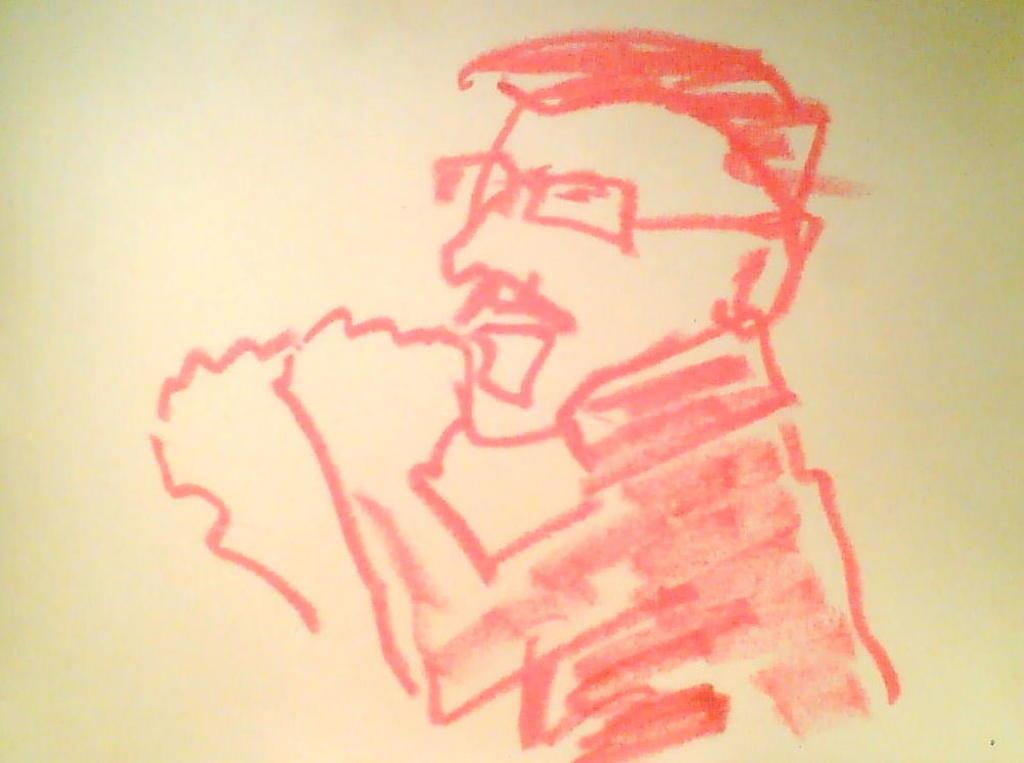What is depicted in the image? There is a sketch of a person in the image. What color is the sketch? The sketch is in red color. What color is the background of the image? The background of the image is white. What type of net can be seen in the image? There is no net present in the image; it features a sketch of a person in red color with a white background. 